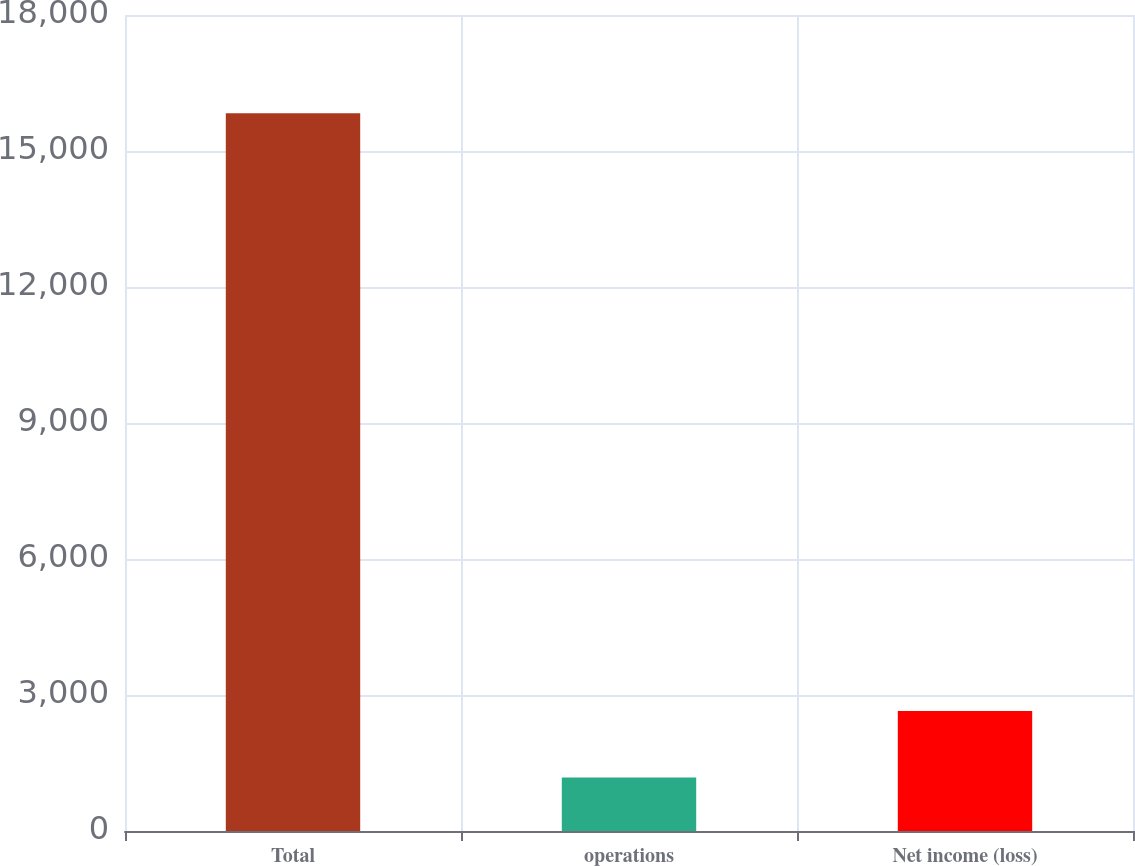Convert chart. <chart><loc_0><loc_0><loc_500><loc_500><bar_chart><fcel>Total<fcel>operations<fcel>Net income (loss)<nl><fcel>15832<fcel>1181<fcel>2646.1<nl></chart> 